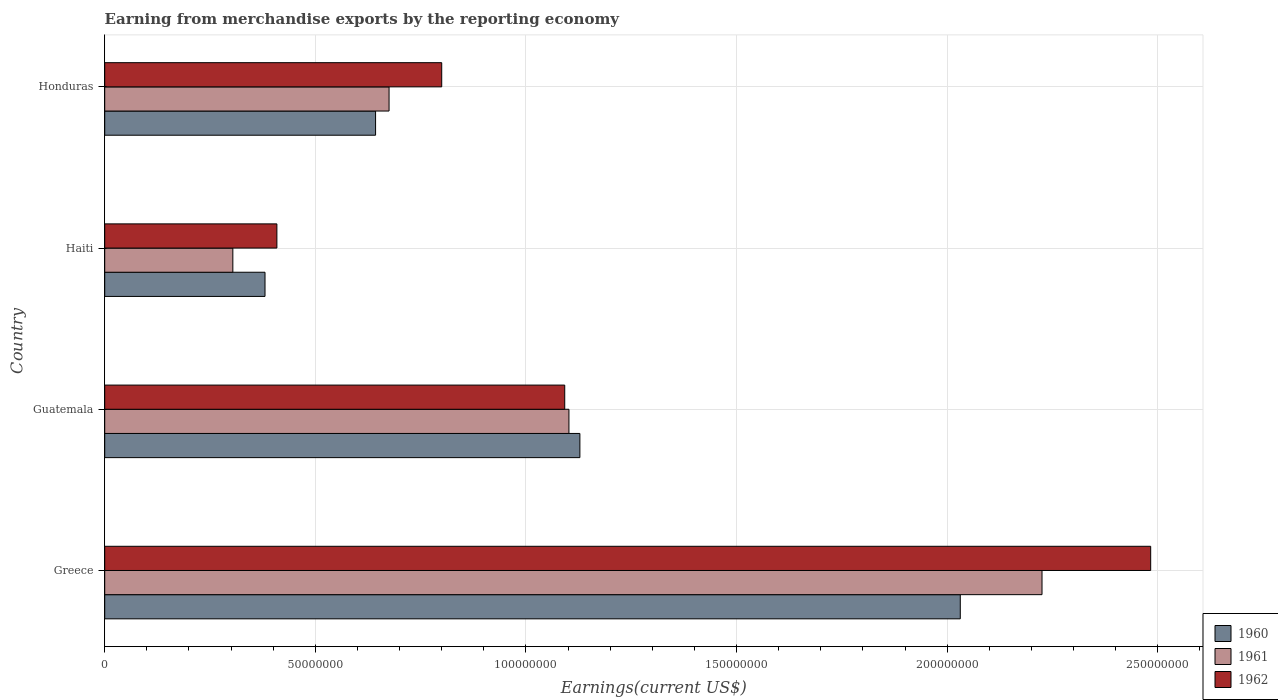How many different coloured bars are there?
Provide a short and direct response. 3. Are the number of bars per tick equal to the number of legend labels?
Offer a terse response. Yes. Are the number of bars on each tick of the Y-axis equal?
Your answer should be very brief. Yes. How many bars are there on the 3rd tick from the bottom?
Keep it short and to the point. 3. What is the label of the 1st group of bars from the top?
Give a very brief answer. Honduras. What is the amount earned from merchandise exports in 1960 in Guatemala?
Give a very brief answer. 1.13e+08. Across all countries, what is the maximum amount earned from merchandise exports in 1960?
Give a very brief answer. 2.03e+08. Across all countries, what is the minimum amount earned from merchandise exports in 1960?
Provide a short and direct response. 3.81e+07. In which country was the amount earned from merchandise exports in 1962 maximum?
Provide a short and direct response. Greece. In which country was the amount earned from merchandise exports in 1960 minimum?
Your answer should be compact. Haiti. What is the total amount earned from merchandise exports in 1960 in the graph?
Your answer should be compact. 4.18e+08. What is the difference between the amount earned from merchandise exports in 1962 in Greece and that in Haiti?
Give a very brief answer. 2.07e+08. What is the difference between the amount earned from merchandise exports in 1961 in Guatemala and the amount earned from merchandise exports in 1962 in Greece?
Make the answer very short. -1.38e+08. What is the average amount earned from merchandise exports in 1960 per country?
Offer a very short reply. 1.05e+08. What is the difference between the amount earned from merchandise exports in 1962 and amount earned from merchandise exports in 1960 in Guatemala?
Your answer should be compact. -3.60e+06. What is the ratio of the amount earned from merchandise exports in 1962 in Haiti to that in Honduras?
Provide a succinct answer. 0.51. Is the difference between the amount earned from merchandise exports in 1962 in Greece and Honduras greater than the difference between the amount earned from merchandise exports in 1960 in Greece and Honduras?
Make the answer very short. Yes. What is the difference between the highest and the second highest amount earned from merchandise exports in 1960?
Provide a short and direct response. 9.03e+07. What is the difference between the highest and the lowest amount earned from merchandise exports in 1961?
Provide a short and direct response. 1.92e+08. Is the sum of the amount earned from merchandise exports in 1961 in Haiti and Honduras greater than the maximum amount earned from merchandise exports in 1962 across all countries?
Offer a terse response. No. What does the 1st bar from the top in Guatemala represents?
Ensure brevity in your answer.  1962. What does the 2nd bar from the bottom in Honduras represents?
Keep it short and to the point. 1961. Is it the case that in every country, the sum of the amount earned from merchandise exports in 1960 and amount earned from merchandise exports in 1962 is greater than the amount earned from merchandise exports in 1961?
Ensure brevity in your answer.  Yes. Are all the bars in the graph horizontal?
Ensure brevity in your answer.  Yes. How many countries are there in the graph?
Your response must be concise. 4. What is the difference between two consecutive major ticks on the X-axis?
Provide a succinct answer. 5.00e+07. What is the title of the graph?
Provide a short and direct response. Earning from merchandise exports by the reporting economy. Does "2009" appear as one of the legend labels in the graph?
Your response must be concise. No. What is the label or title of the X-axis?
Your answer should be very brief. Earnings(current US$). What is the Earnings(current US$) in 1960 in Greece?
Give a very brief answer. 2.03e+08. What is the Earnings(current US$) in 1961 in Greece?
Your answer should be very brief. 2.22e+08. What is the Earnings(current US$) in 1962 in Greece?
Your answer should be compact. 2.48e+08. What is the Earnings(current US$) in 1960 in Guatemala?
Provide a short and direct response. 1.13e+08. What is the Earnings(current US$) in 1961 in Guatemala?
Offer a terse response. 1.10e+08. What is the Earnings(current US$) in 1962 in Guatemala?
Offer a very short reply. 1.09e+08. What is the Earnings(current US$) of 1960 in Haiti?
Offer a very short reply. 3.81e+07. What is the Earnings(current US$) in 1961 in Haiti?
Make the answer very short. 3.04e+07. What is the Earnings(current US$) in 1962 in Haiti?
Your answer should be very brief. 4.09e+07. What is the Earnings(current US$) in 1960 in Honduras?
Your answer should be very brief. 6.43e+07. What is the Earnings(current US$) in 1961 in Honduras?
Give a very brief answer. 6.75e+07. What is the Earnings(current US$) in 1962 in Honduras?
Make the answer very short. 8.00e+07. Across all countries, what is the maximum Earnings(current US$) of 1960?
Keep it short and to the point. 2.03e+08. Across all countries, what is the maximum Earnings(current US$) in 1961?
Offer a very short reply. 2.22e+08. Across all countries, what is the maximum Earnings(current US$) of 1962?
Make the answer very short. 2.48e+08. Across all countries, what is the minimum Earnings(current US$) in 1960?
Offer a very short reply. 3.81e+07. Across all countries, what is the minimum Earnings(current US$) of 1961?
Ensure brevity in your answer.  3.04e+07. Across all countries, what is the minimum Earnings(current US$) of 1962?
Give a very brief answer. 4.09e+07. What is the total Earnings(current US$) of 1960 in the graph?
Provide a short and direct response. 4.18e+08. What is the total Earnings(current US$) in 1961 in the graph?
Keep it short and to the point. 4.31e+08. What is the total Earnings(current US$) of 1962 in the graph?
Your answer should be compact. 4.78e+08. What is the difference between the Earnings(current US$) in 1960 in Greece and that in Guatemala?
Your answer should be very brief. 9.03e+07. What is the difference between the Earnings(current US$) in 1961 in Greece and that in Guatemala?
Provide a succinct answer. 1.12e+08. What is the difference between the Earnings(current US$) in 1962 in Greece and that in Guatemala?
Provide a succinct answer. 1.39e+08. What is the difference between the Earnings(current US$) in 1960 in Greece and that in Haiti?
Give a very brief answer. 1.65e+08. What is the difference between the Earnings(current US$) in 1961 in Greece and that in Haiti?
Make the answer very short. 1.92e+08. What is the difference between the Earnings(current US$) of 1962 in Greece and that in Haiti?
Offer a terse response. 2.07e+08. What is the difference between the Earnings(current US$) in 1960 in Greece and that in Honduras?
Your response must be concise. 1.39e+08. What is the difference between the Earnings(current US$) in 1961 in Greece and that in Honduras?
Your answer should be very brief. 1.55e+08. What is the difference between the Earnings(current US$) in 1962 in Greece and that in Honduras?
Offer a very short reply. 1.68e+08. What is the difference between the Earnings(current US$) in 1960 in Guatemala and that in Haiti?
Keep it short and to the point. 7.47e+07. What is the difference between the Earnings(current US$) in 1961 in Guatemala and that in Haiti?
Provide a succinct answer. 7.98e+07. What is the difference between the Earnings(current US$) in 1962 in Guatemala and that in Haiti?
Keep it short and to the point. 6.83e+07. What is the difference between the Earnings(current US$) in 1960 in Guatemala and that in Honduras?
Provide a succinct answer. 4.85e+07. What is the difference between the Earnings(current US$) of 1961 in Guatemala and that in Honduras?
Your answer should be very brief. 4.27e+07. What is the difference between the Earnings(current US$) of 1962 in Guatemala and that in Honduras?
Ensure brevity in your answer.  2.92e+07. What is the difference between the Earnings(current US$) of 1960 in Haiti and that in Honduras?
Give a very brief answer. -2.62e+07. What is the difference between the Earnings(current US$) of 1961 in Haiti and that in Honduras?
Your answer should be compact. -3.71e+07. What is the difference between the Earnings(current US$) of 1962 in Haiti and that in Honduras?
Ensure brevity in your answer.  -3.91e+07. What is the difference between the Earnings(current US$) of 1960 in Greece and the Earnings(current US$) of 1961 in Guatemala?
Ensure brevity in your answer.  9.29e+07. What is the difference between the Earnings(current US$) of 1960 in Greece and the Earnings(current US$) of 1962 in Guatemala?
Provide a succinct answer. 9.39e+07. What is the difference between the Earnings(current US$) of 1961 in Greece and the Earnings(current US$) of 1962 in Guatemala?
Make the answer very short. 1.13e+08. What is the difference between the Earnings(current US$) in 1960 in Greece and the Earnings(current US$) in 1961 in Haiti?
Your answer should be very brief. 1.73e+08. What is the difference between the Earnings(current US$) in 1960 in Greece and the Earnings(current US$) in 1962 in Haiti?
Keep it short and to the point. 1.62e+08. What is the difference between the Earnings(current US$) of 1961 in Greece and the Earnings(current US$) of 1962 in Haiti?
Provide a succinct answer. 1.82e+08. What is the difference between the Earnings(current US$) in 1960 in Greece and the Earnings(current US$) in 1961 in Honduras?
Offer a very short reply. 1.36e+08. What is the difference between the Earnings(current US$) of 1960 in Greece and the Earnings(current US$) of 1962 in Honduras?
Your answer should be compact. 1.23e+08. What is the difference between the Earnings(current US$) of 1961 in Greece and the Earnings(current US$) of 1962 in Honduras?
Offer a very short reply. 1.42e+08. What is the difference between the Earnings(current US$) of 1960 in Guatemala and the Earnings(current US$) of 1961 in Haiti?
Keep it short and to the point. 8.24e+07. What is the difference between the Earnings(current US$) in 1960 in Guatemala and the Earnings(current US$) in 1962 in Haiti?
Give a very brief answer. 7.19e+07. What is the difference between the Earnings(current US$) of 1961 in Guatemala and the Earnings(current US$) of 1962 in Haiti?
Provide a short and direct response. 6.93e+07. What is the difference between the Earnings(current US$) of 1960 in Guatemala and the Earnings(current US$) of 1961 in Honduras?
Keep it short and to the point. 4.53e+07. What is the difference between the Earnings(current US$) of 1960 in Guatemala and the Earnings(current US$) of 1962 in Honduras?
Offer a very short reply. 3.28e+07. What is the difference between the Earnings(current US$) in 1961 in Guatemala and the Earnings(current US$) in 1962 in Honduras?
Ensure brevity in your answer.  3.02e+07. What is the difference between the Earnings(current US$) in 1960 in Haiti and the Earnings(current US$) in 1961 in Honduras?
Offer a very short reply. -2.94e+07. What is the difference between the Earnings(current US$) in 1960 in Haiti and the Earnings(current US$) in 1962 in Honduras?
Give a very brief answer. -4.19e+07. What is the difference between the Earnings(current US$) of 1961 in Haiti and the Earnings(current US$) of 1962 in Honduras?
Ensure brevity in your answer.  -4.96e+07. What is the average Earnings(current US$) of 1960 per country?
Your response must be concise. 1.05e+08. What is the average Earnings(current US$) of 1961 per country?
Offer a terse response. 1.08e+08. What is the average Earnings(current US$) in 1962 per country?
Make the answer very short. 1.20e+08. What is the difference between the Earnings(current US$) in 1960 and Earnings(current US$) in 1961 in Greece?
Provide a short and direct response. -1.94e+07. What is the difference between the Earnings(current US$) of 1960 and Earnings(current US$) of 1962 in Greece?
Give a very brief answer. -4.52e+07. What is the difference between the Earnings(current US$) of 1961 and Earnings(current US$) of 1962 in Greece?
Provide a succinct answer. -2.58e+07. What is the difference between the Earnings(current US$) of 1960 and Earnings(current US$) of 1961 in Guatemala?
Your response must be concise. 2.60e+06. What is the difference between the Earnings(current US$) in 1960 and Earnings(current US$) in 1962 in Guatemala?
Make the answer very short. 3.60e+06. What is the difference between the Earnings(current US$) in 1961 and Earnings(current US$) in 1962 in Guatemala?
Provide a short and direct response. 1.00e+06. What is the difference between the Earnings(current US$) of 1960 and Earnings(current US$) of 1961 in Haiti?
Offer a very short reply. 7.64e+06. What is the difference between the Earnings(current US$) in 1960 and Earnings(current US$) in 1962 in Haiti?
Provide a succinct answer. -2.82e+06. What is the difference between the Earnings(current US$) of 1961 and Earnings(current US$) of 1962 in Haiti?
Provide a succinct answer. -1.05e+07. What is the difference between the Earnings(current US$) in 1960 and Earnings(current US$) in 1961 in Honduras?
Provide a succinct answer. -3.20e+06. What is the difference between the Earnings(current US$) in 1960 and Earnings(current US$) in 1962 in Honduras?
Ensure brevity in your answer.  -1.57e+07. What is the difference between the Earnings(current US$) in 1961 and Earnings(current US$) in 1962 in Honduras?
Keep it short and to the point. -1.25e+07. What is the ratio of the Earnings(current US$) of 1960 in Greece to that in Guatemala?
Offer a very short reply. 1.8. What is the ratio of the Earnings(current US$) in 1961 in Greece to that in Guatemala?
Provide a short and direct response. 2.02. What is the ratio of the Earnings(current US$) in 1962 in Greece to that in Guatemala?
Offer a very short reply. 2.27. What is the ratio of the Earnings(current US$) of 1960 in Greece to that in Haiti?
Your response must be concise. 5.34. What is the ratio of the Earnings(current US$) in 1961 in Greece to that in Haiti?
Your answer should be compact. 7.32. What is the ratio of the Earnings(current US$) of 1962 in Greece to that in Haiti?
Make the answer very short. 6.08. What is the ratio of the Earnings(current US$) in 1960 in Greece to that in Honduras?
Provide a succinct answer. 3.16. What is the ratio of the Earnings(current US$) of 1961 in Greece to that in Honduras?
Make the answer very short. 3.3. What is the ratio of the Earnings(current US$) of 1962 in Greece to that in Honduras?
Your answer should be very brief. 3.1. What is the ratio of the Earnings(current US$) of 1960 in Guatemala to that in Haiti?
Provide a succinct answer. 2.96. What is the ratio of the Earnings(current US$) of 1961 in Guatemala to that in Haiti?
Offer a very short reply. 3.62. What is the ratio of the Earnings(current US$) in 1962 in Guatemala to that in Haiti?
Offer a terse response. 2.67. What is the ratio of the Earnings(current US$) in 1960 in Guatemala to that in Honduras?
Provide a succinct answer. 1.75. What is the ratio of the Earnings(current US$) in 1961 in Guatemala to that in Honduras?
Keep it short and to the point. 1.63. What is the ratio of the Earnings(current US$) of 1962 in Guatemala to that in Honduras?
Offer a terse response. 1.36. What is the ratio of the Earnings(current US$) of 1960 in Haiti to that in Honduras?
Offer a terse response. 0.59. What is the ratio of the Earnings(current US$) in 1961 in Haiti to that in Honduras?
Offer a terse response. 0.45. What is the ratio of the Earnings(current US$) in 1962 in Haiti to that in Honduras?
Keep it short and to the point. 0.51. What is the difference between the highest and the second highest Earnings(current US$) of 1960?
Give a very brief answer. 9.03e+07. What is the difference between the highest and the second highest Earnings(current US$) of 1961?
Provide a short and direct response. 1.12e+08. What is the difference between the highest and the second highest Earnings(current US$) in 1962?
Your answer should be very brief. 1.39e+08. What is the difference between the highest and the lowest Earnings(current US$) of 1960?
Make the answer very short. 1.65e+08. What is the difference between the highest and the lowest Earnings(current US$) in 1961?
Make the answer very short. 1.92e+08. What is the difference between the highest and the lowest Earnings(current US$) of 1962?
Provide a short and direct response. 2.07e+08. 